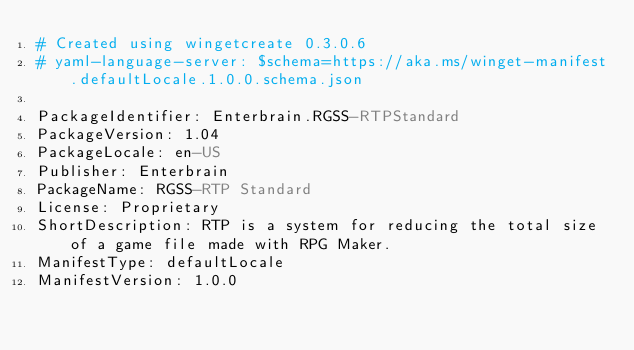<code> <loc_0><loc_0><loc_500><loc_500><_YAML_># Created using wingetcreate 0.3.0.6
# yaml-language-server: $schema=https://aka.ms/winget-manifest.defaultLocale.1.0.0.schema.json

PackageIdentifier: Enterbrain.RGSS-RTPStandard
PackageVersion: 1.04
PackageLocale: en-US
Publisher: Enterbrain
PackageName: RGSS-RTP Standard
License: Proprietary
ShortDescription: RTP is a system for reducing the total size of a game file made with RPG Maker.
ManifestType: defaultLocale
ManifestVersion: 1.0.0

</code> 